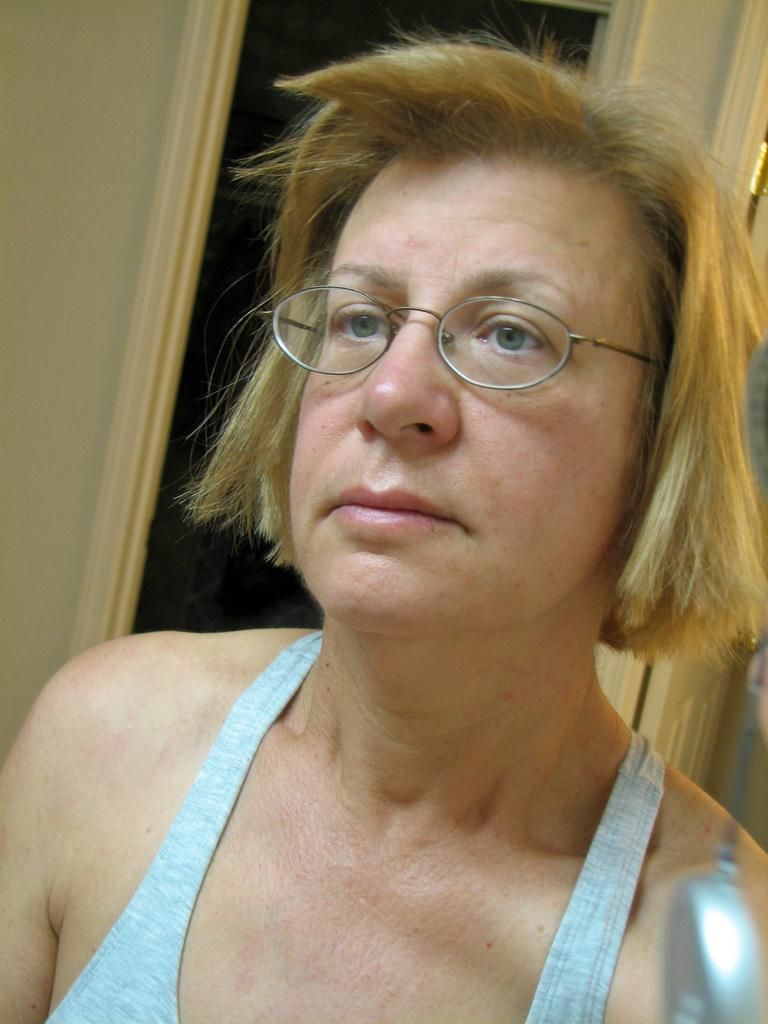Who is present in the image? There is a woman in the image. What accessory is the woman wearing? The woman is wearing spectacles. What architectural feature can be seen in the image? There is a door visible in the image. What type of toothpaste is the woman using in the image? There is no toothpaste present in the image, and the woman is not using any toothpaste. How many windows are visible in the image? There are no windows visible in the image; only a door is present. 